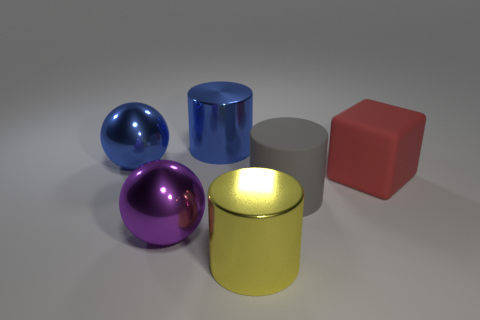Do the purple metallic thing and the shiny thing left of the purple object have the same shape? Indeed, the purple metallic sphere and the shiny blue sphere to its left do share the same spherical shape. Both exhibit a high-gloss finish that reflects the environment, contributing to their lustrous appearance. 